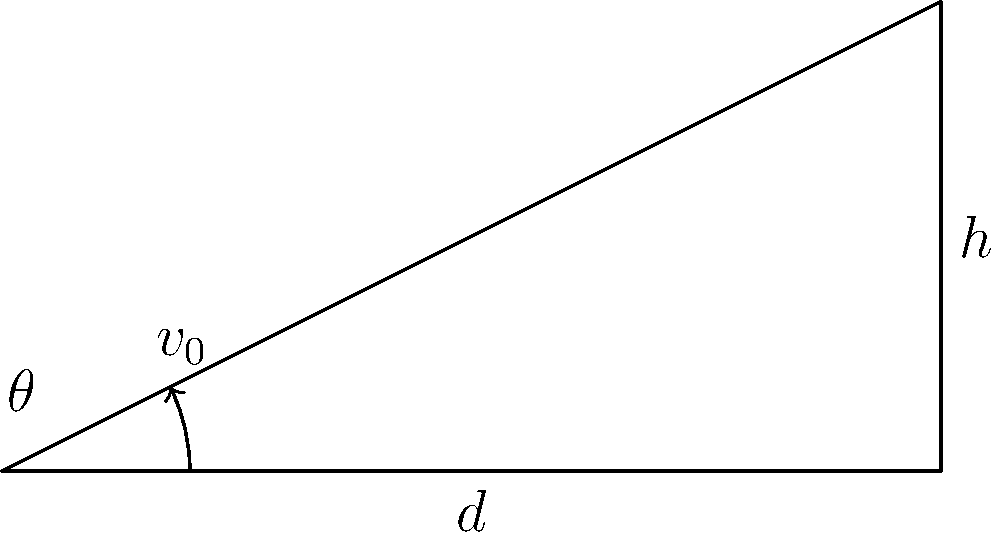As an SEO specialist for sports websites, you're creating content about soccer ball trajectories. A player kicks a soccer ball with an initial velocity ($v_0$) of 20 m/s, and it travels a horizontal distance ($d$) of 40 meters before hitting the ground. Assuming no air resistance, what is the angle of trajectory ($\theta$) in degrees? To solve this problem, we'll use the equation for the range of a projectile:

$$d = \frac{v_0^2 \sin(2\theta)}{g}$$

Where:
$d$ = horizontal distance
$v_0$ = initial velocity
$\theta$ = angle of trajectory
$g$ = acceleration due to gravity (9.8 m/s²)

Steps:
1) Substitute the known values into the equation:
   $$40 = \frac{20^2 \sin(2\theta)}{9.8}$$

2) Simplify:
   $$40 = \frac{400 \sin(2\theta)}{9.8}$$

3) Multiply both sides by 9.8:
   $$392 = 400 \sin(2\theta)$$

4) Divide both sides by 400:
   $$0.98 = \sin(2\theta)$$

5) Take the inverse sine (arcsin) of both sides:
   $$\arcsin(0.98) = 2\theta$$

6) Solve for $\theta$:
   $$\theta = \frac{\arcsin(0.98)}{2}$$

7) Calculate the result:
   $$\theta = \frac{1.3962}{2} = 0.6981 \text{ radians}$$

8) Convert to degrees:
   $$\theta = 0.6981 \times \frac{180}{\pi} = 40.0°$$

Therefore, the angle of trajectory is approximately 40.0 degrees.
Answer: 40.0° 